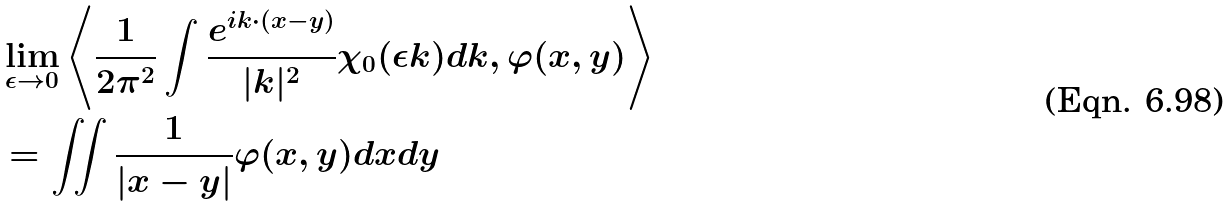<formula> <loc_0><loc_0><loc_500><loc_500>& \lim _ { \epsilon \rightarrow 0 } \left < \frac { 1 } { 2 \pi ^ { 2 } } \int \frac { e ^ { i k \cdot ( x - y ) } } { | k | ^ { 2 } } \chi _ { 0 } ( \epsilon k ) d k , \varphi ( x , y ) \right > \\ & = \iint \frac { 1 } { | x - y | } \varphi ( x , y ) d x d y</formula> 